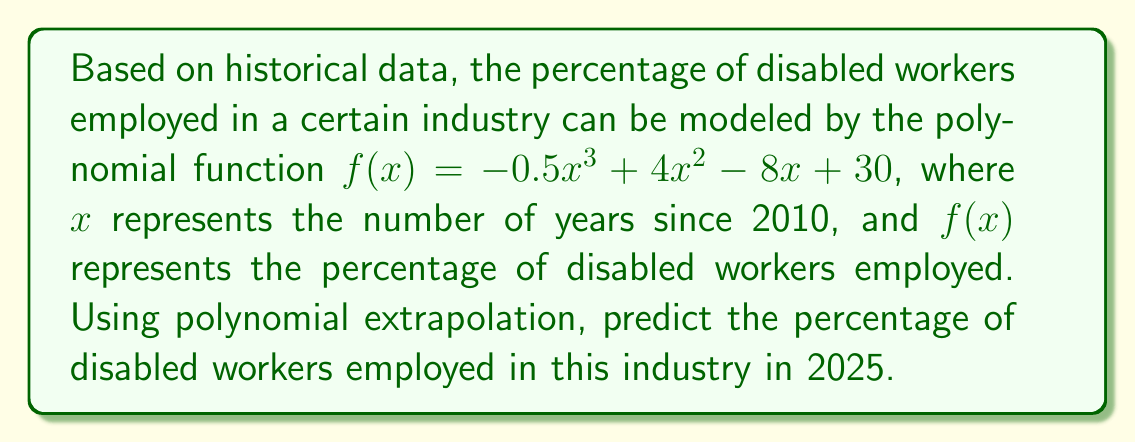What is the answer to this math problem? To solve this problem, we need to follow these steps:

1. Identify the year we're predicting for: 2025

2. Calculate how many years this is from our base year (2010):
   2025 - 2010 = 15 years

3. Substitute x = 15 into our polynomial function:
   $f(15) = -0.5(15)^3 + 4(15)^2 - 8(15) + 30$

4. Evaluate the function:
   $f(15) = -0.5(3375) + 4(225) - 8(15) + 30$
   $f(15) = -1687.5 + 900 - 120 + 30$
   $f(15) = -877.5$

5. Interpret the result:
   The negative value indicates that our polynomial model breaks down for extrapolation this far into the future. In reality, the percentage of employed workers cannot be negative.

6. Conclusion:
   This polynomial model is not suitable for long-term predictions beyond its valid range. In practice, we would need to adjust our model or use more sophisticated forecasting techniques for accurate long-term predictions of employment trends for disabled workers.
Answer: The model predicts -877.5%, which is invalid, indicating the polynomial is unsuitable for long-term extrapolation. 